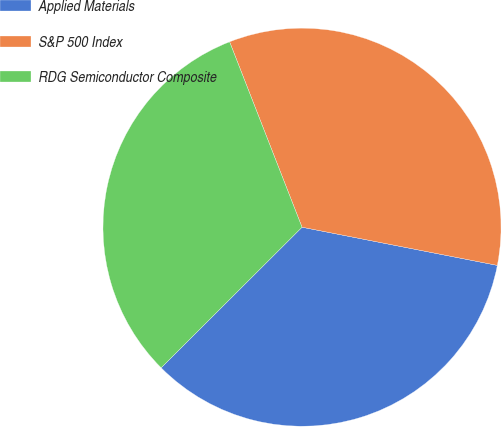<chart> <loc_0><loc_0><loc_500><loc_500><pie_chart><fcel>Applied Materials<fcel>S&P 500 Index<fcel>RDG Semiconductor Composite<nl><fcel>34.44%<fcel>34.0%<fcel>31.56%<nl></chart> 